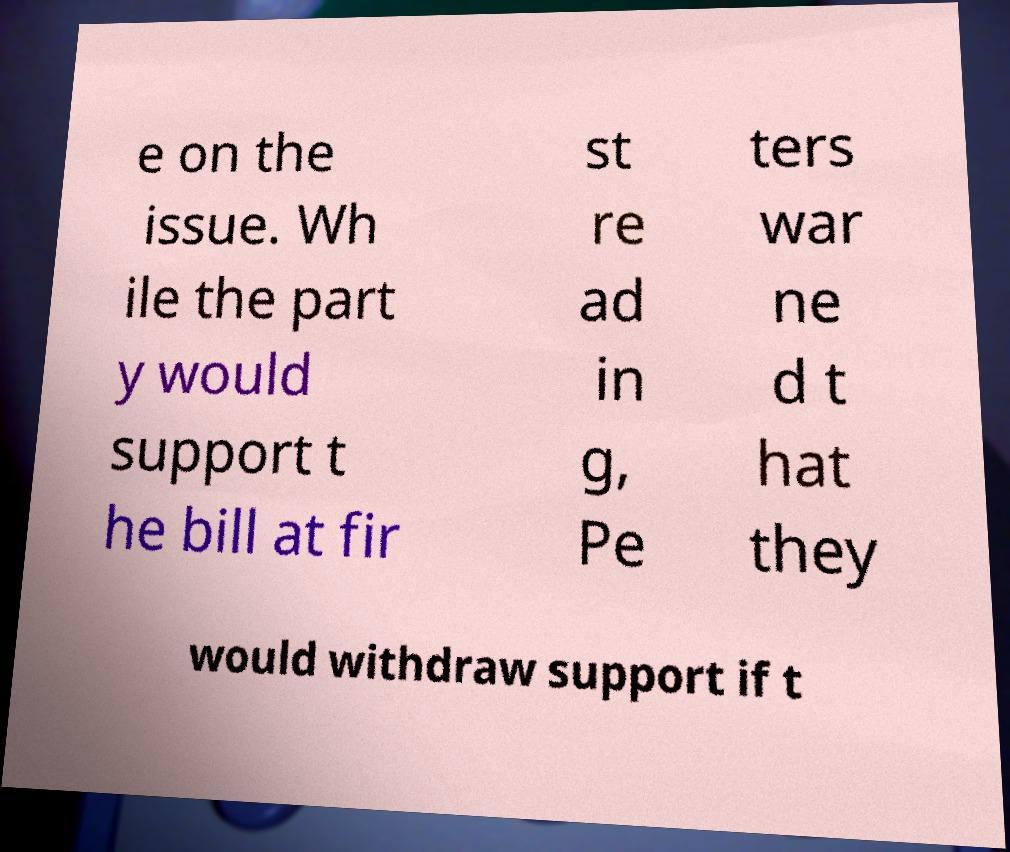Could you extract and type out the text from this image? e on the issue. Wh ile the part y would support t he bill at fir st re ad in g, Pe ters war ne d t hat they would withdraw support if t 